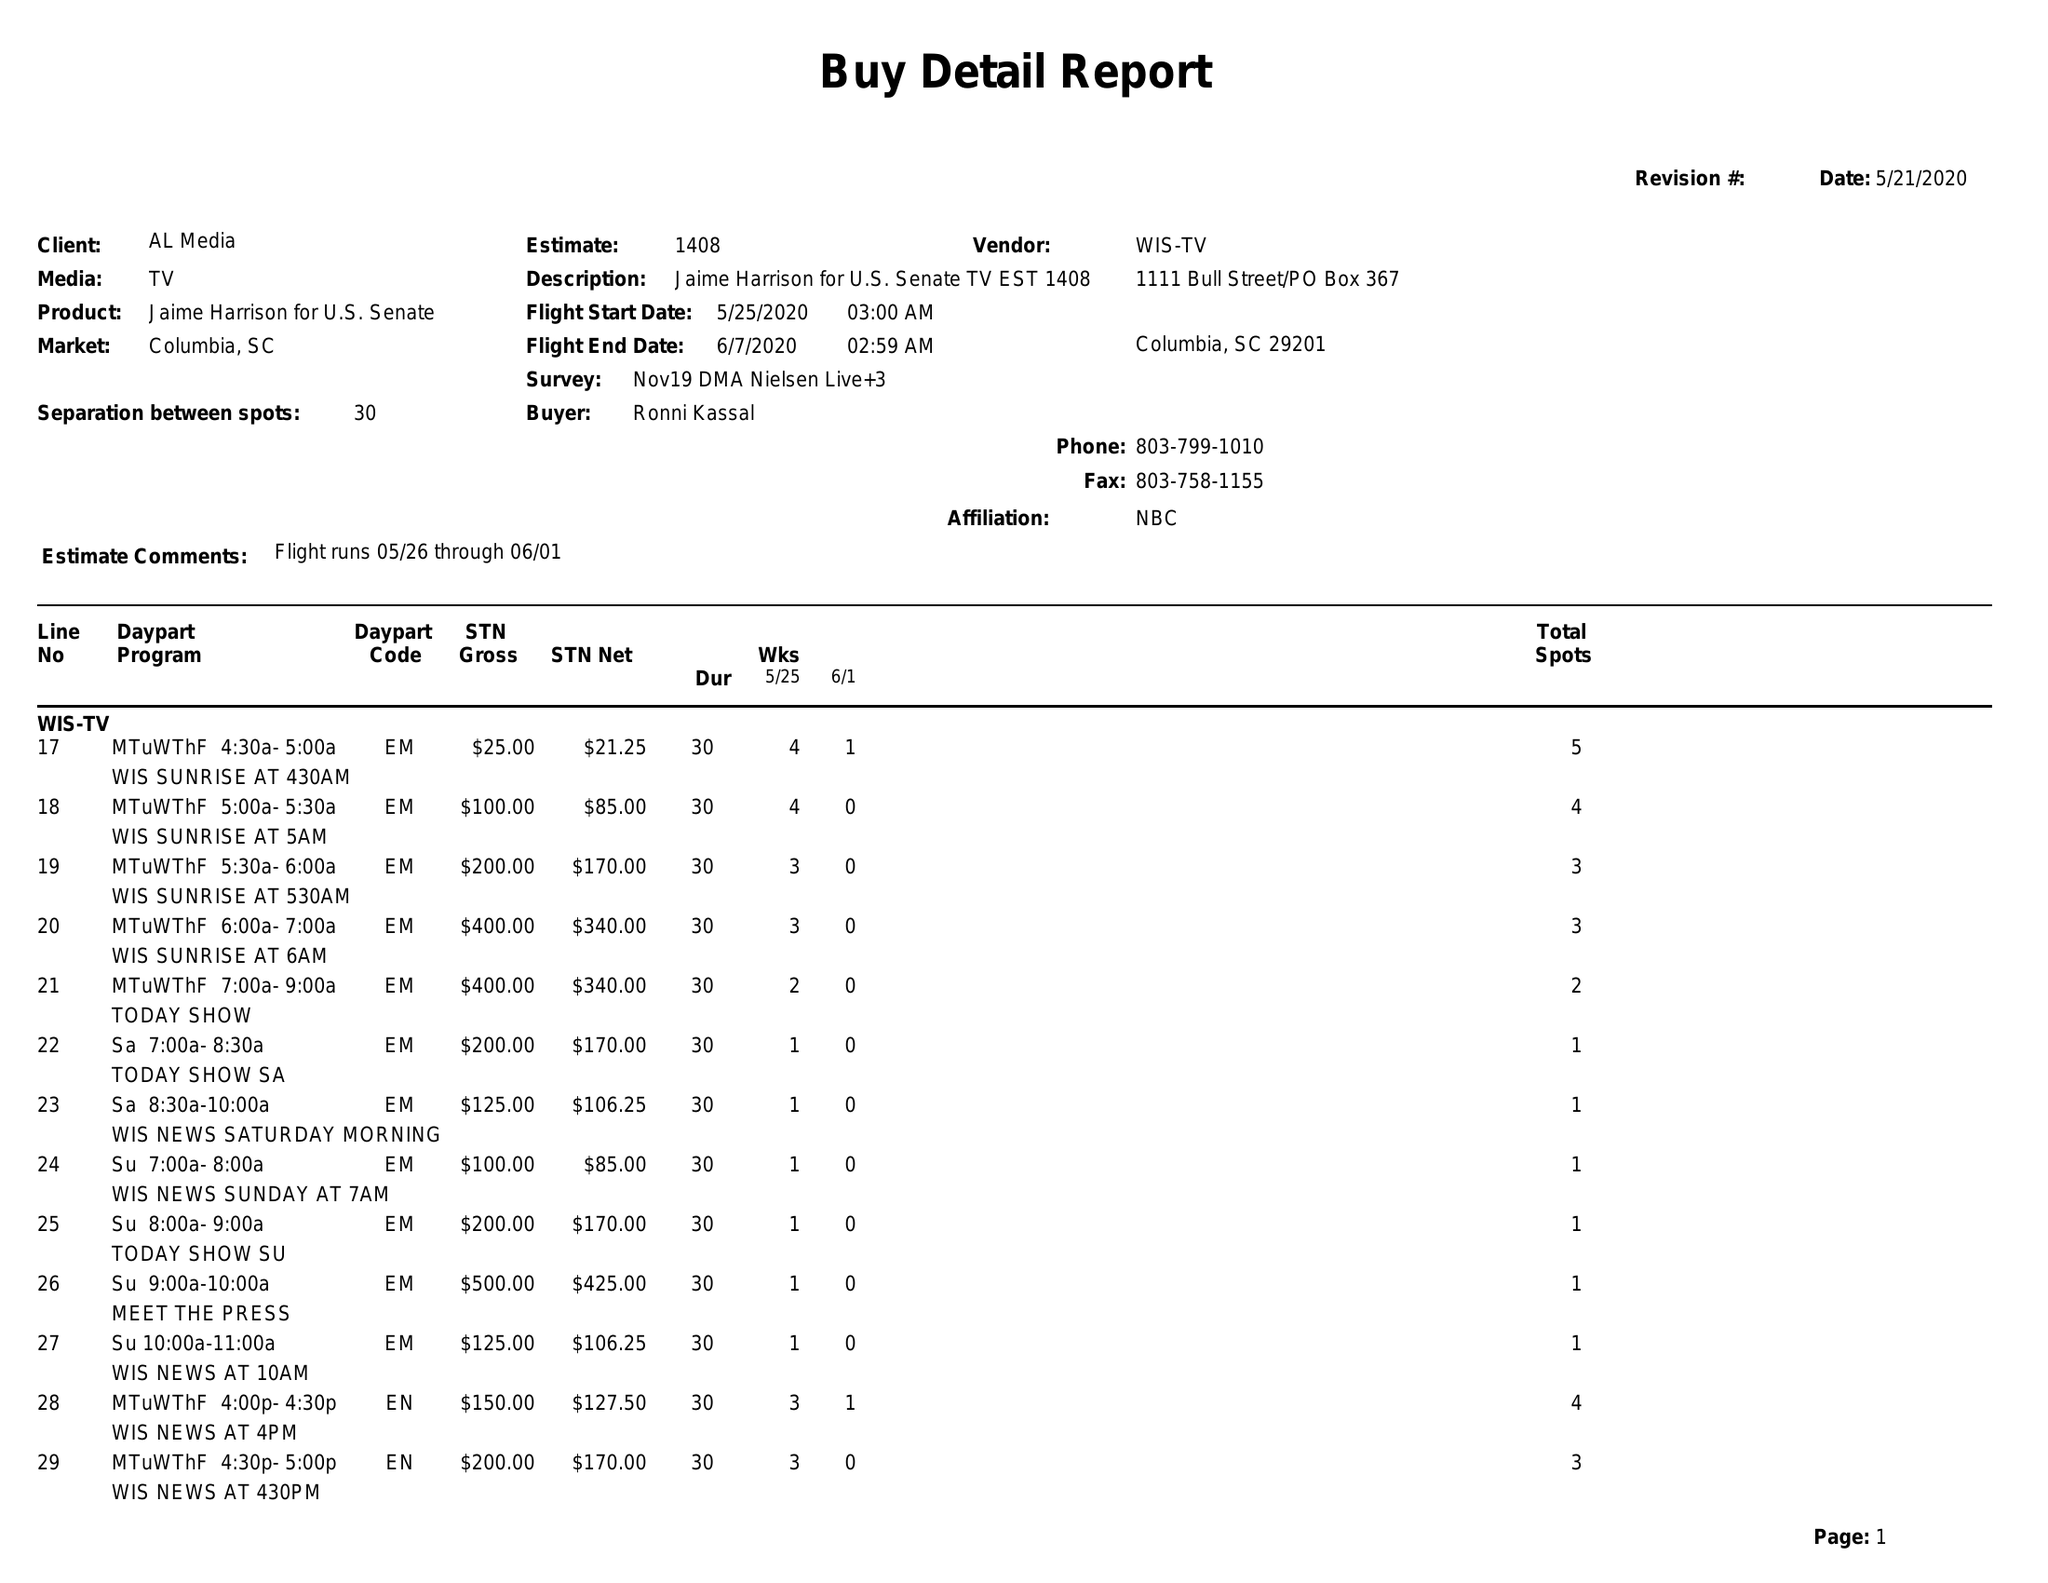What is the value for the flight_from?
Answer the question using a single word or phrase. 05/25/20 